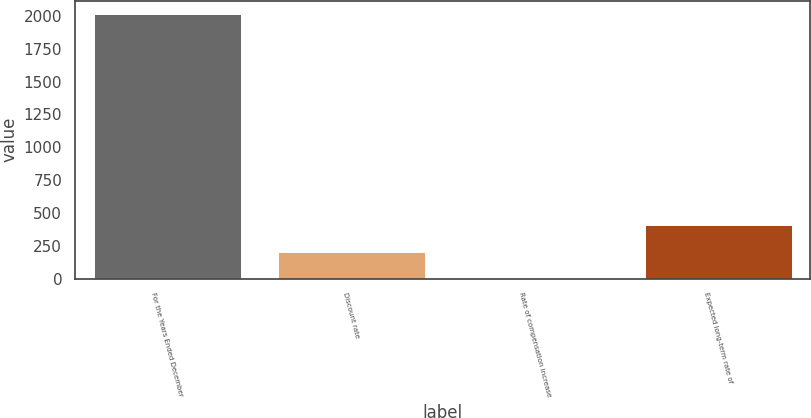Convert chart to OTSL. <chart><loc_0><loc_0><loc_500><loc_500><bar_chart><fcel>For the Years Ended December<fcel>Discount rate<fcel>Rate of compensation increase<fcel>Expected long-term rate of<nl><fcel>2013<fcel>204.26<fcel>3.29<fcel>405.23<nl></chart> 